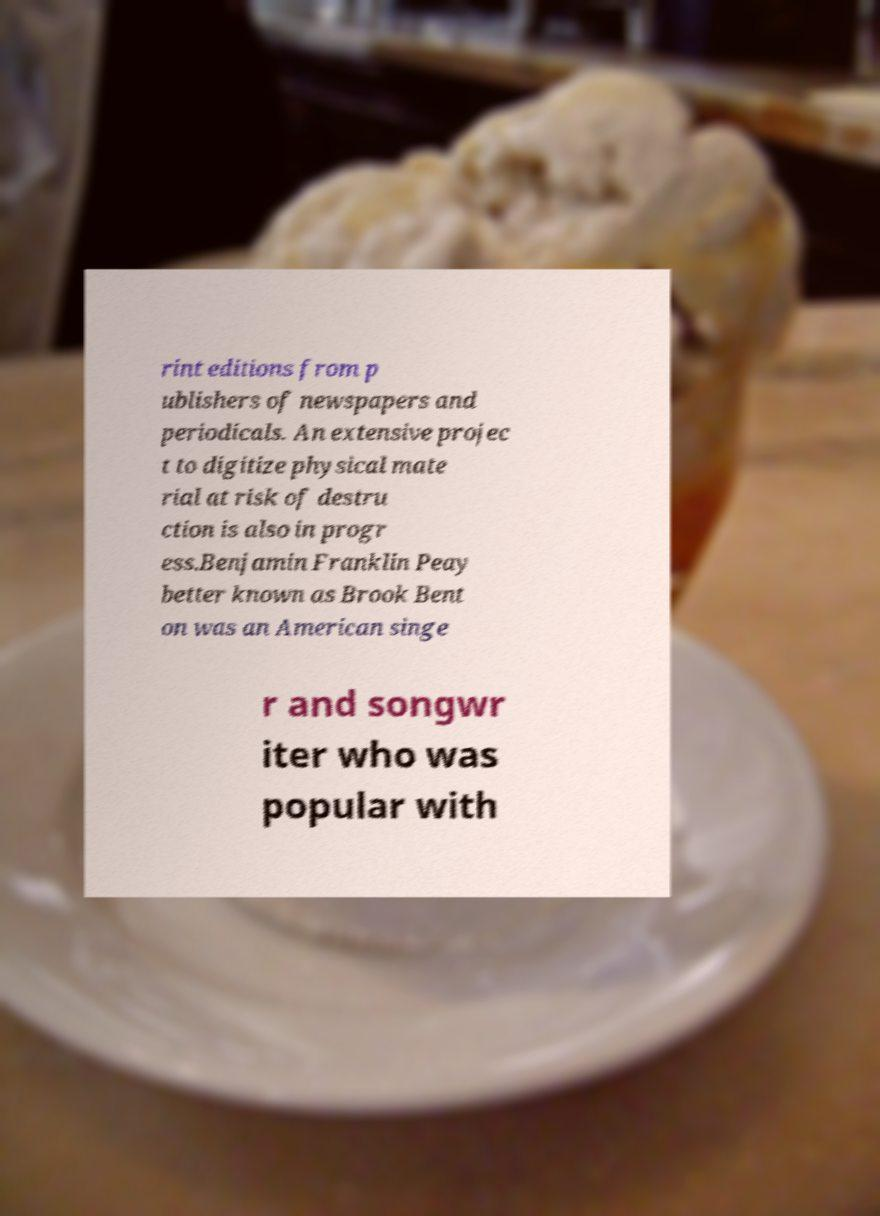Please identify and transcribe the text found in this image. rint editions from p ublishers of newspapers and periodicals. An extensive projec t to digitize physical mate rial at risk of destru ction is also in progr ess.Benjamin Franklin Peay better known as Brook Bent on was an American singe r and songwr iter who was popular with 